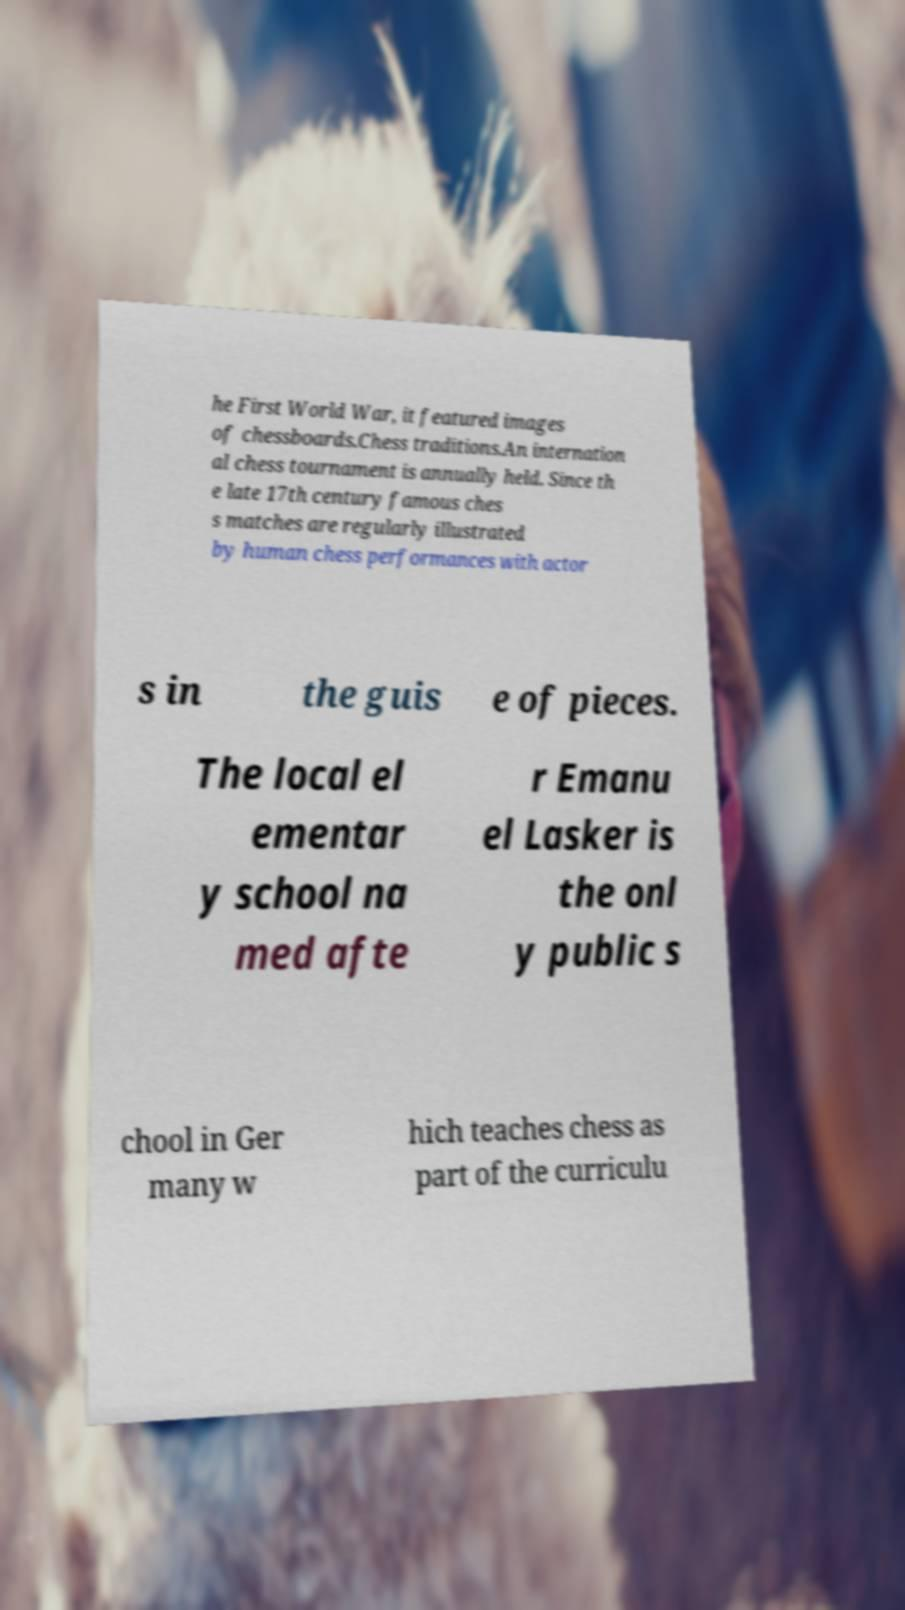Please identify and transcribe the text found in this image. he First World War, it featured images of chessboards.Chess traditions.An internation al chess tournament is annually held. Since th e late 17th century famous ches s matches are regularly illustrated by human chess performances with actor s in the guis e of pieces. The local el ementar y school na med afte r Emanu el Lasker is the onl y public s chool in Ger many w hich teaches chess as part of the curriculu 